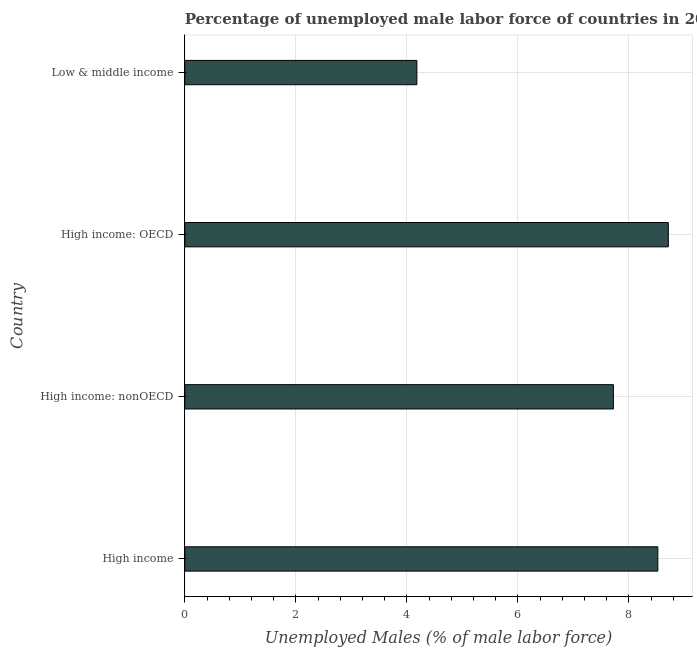What is the title of the graph?
Make the answer very short. Percentage of unemployed male labor force of countries in 2010. What is the label or title of the X-axis?
Provide a succinct answer. Unemployed Males (% of male labor force). What is the label or title of the Y-axis?
Ensure brevity in your answer.  Country. What is the total unemployed male labour force in High income: OECD?
Your answer should be very brief. 8.71. Across all countries, what is the maximum total unemployed male labour force?
Ensure brevity in your answer.  8.71. Across all countries, what is the minimum total unemployed male labour force?
Offer a very short reply. 4.18. In which country was the total unemployed male labour force maximum?
Your answer should be very brief. High income: OECD. In which country was the total unemployed male labour force minimum?
Your answer should be compact. Low & middle income. What is the sum of the total unemployed male labour force?
Offer a terse response. 29.14. What is the difference between the total unemployed male labour force in High income and High income: nonOECD?
Ensure brevity in your answer.  0.8. What is the average total unemployed male labour force per country?
Make the answer very short. 7.28. What is the median total unemployed male labour force?
Offer a very short reply. 8.12. In how many countries, is the total unemployed male labour force greater than 7.6 %?
Offer a terse response. 3. What is the ratio of the total unemployed male labour force in High income to that in High income: nonOECD?
Keep it short and to the point. 1.1. Is the total unemployed male labour force in High income: nonOECD less than that in Low & middle income?
Provide a succinct answer. No. Is the difference between the total unemployed male labour force in High income: OECD and High income: nonOECD greater than the difference between any two countries?
Give a very brief answer. No. What is the difference between the highest and the second highest total unemployed male labour force?
Your response must be concise. 0.19. Is the sum of the total unemployed male labour force in High income and Low & middle income greater than the maximum total unemployed male labour force across all countries?
Your answer should be very brief. Yes. What is the difference between the highest and the lowest total unemployed male labour force?
Give a very brief answer. 4.53. How many bars are there?
Make the answer very short. 4. Are all the bars in the graph horizontal?
Provide a succinct answer. Yes. What is the difference between two consecutive major ticks on the X-axis?
Ensure brevity in your answer.  2. Are the values on the major ticks of X-axis written in scientific E-notation?
Your answer should be compact. No. What is the Unemployed Males (% of male labor force) of High income?
Make the answer very short. 8.52. What is the Unemployed Males (% of male labor force) of High income: nonOECD?
Provide a short and direct response. 7.72. What is the Unemployed Males (% of male labor force) in High income: OECD?
Ensure brevity in your answer.  8.71. What is the Unemployed Males (% of male labor force) of Low & middle income?
Provide a succinct answer. 4.18. What is the difference between the Unemployed Males (% of male labor force) in High income and High income: nonOECD?
Offer a terse response. 0.8. What is the difference between the Unemployed Males (% of male labor force) in High income and High income: OECD?
Offer a terse response. -0.19. What is the difference between the Unemployed Males (% of male labor force) in High income and Low & middle income?
Ensure brevity in your answer.  4.34. What is the difference between the Unemployed Males (% of male labor force) in High income: nonOECD and High income: OECD?
Keep it short and to the point. -0.99. What is the difference between the Unemployed Males (% of male labor force) in High income: nonOECD and Low & middle income?
Make the answer very short. 3.54. What is the difference between the Unemployed Males (% of male labor force) in High income: OECD and Low & middle income?
Give a very brief answer. 4.53. What is the ratio of the Unemployed Males (% of male labor force) in High income to that in High income: nonOECD?
Ensure brevity in your answer.  1.1. What is the ratio of the Unemployed Males (% of male labor force) in High income to that in Low & middle income?
Provide a short and direct response. 2.04. What is the ratio of the Unemployed Males (% of male labor force) in High income: nonOECD to that in High income: OECD?
Your answer should be compact. 0.89. What is the ratio of the Unemployed Males (% of male labor force) in High income: nonOECD to that in Low & middle income?
Your response must be concise. 1.85. What is the ratio of the Unemployed Males (% of male labor force) in High income: OECD to that in Low & middle income?
Keep it short and to the point. 2.08. 